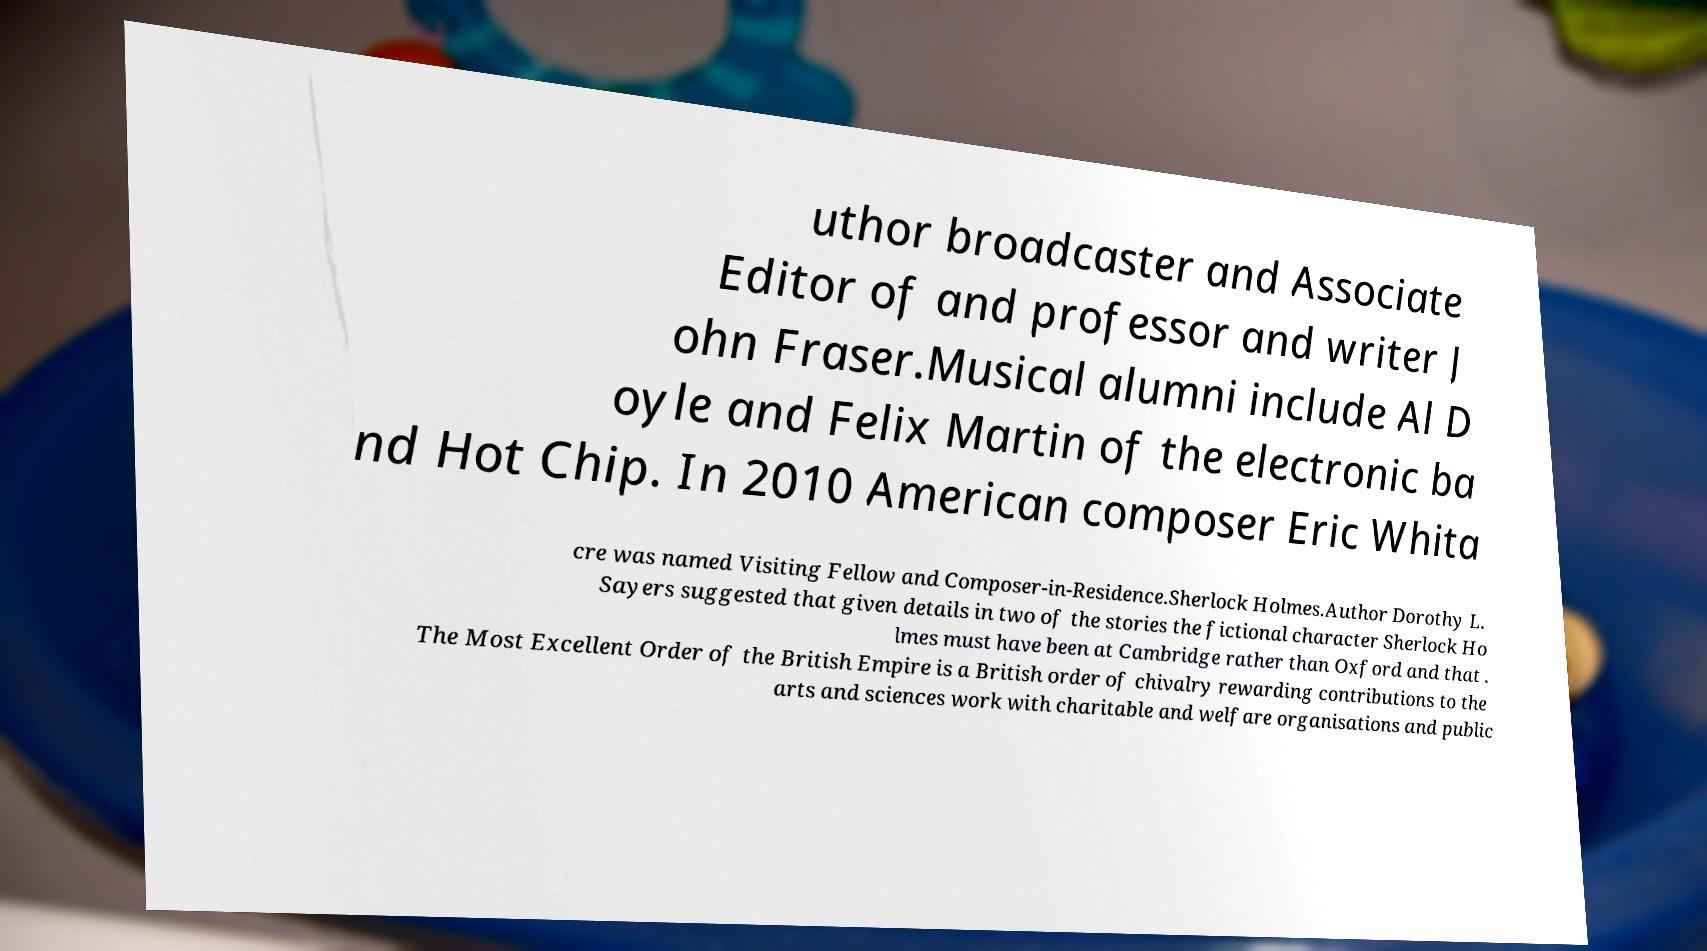I need the written content from this picture converted into text. Can you do that? uthor broadcaster and Associate Editor of and professor and writer J ohn Fraser.Musical alumni include Al D oyle and Felix Martin of the electronic ba nd Hot Chip. In 2010 American composer Eric Whita cre was named Visiting Fellow and Composer-in-Residence.Sherlock Holmes.Author Dorothy L. Sayers suggested that given details in two of the stories the fictional character Sherlock Ho lmes must have been at Cambridge rather than Oxford and that . The Most Excellent Order of the British Empire is a British order of chivalry rewarding contributions to the arts and sciences work with charitable and welfare organisations and public 